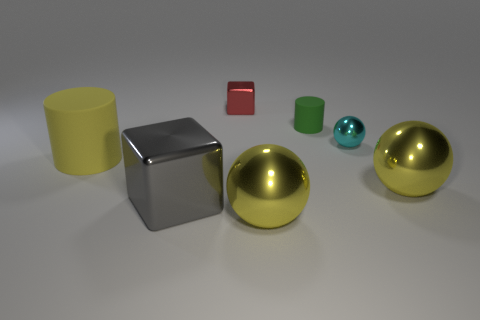Imagining this as an art piece, what concept could it be conveying? Viewing this assembly as an art piece, it might be interpreted as a commentary on order and chaos, the juxtaposition of various geometric forms and finishes could symbolize the diversity of elements in a unified system. The arrangement of the objects, all equidistant and orderly, introduces themes of structure and symmetry, while the different colors and materials can signify diversity within unity. The scene's minimalist aesthetic could further emphasize purity of form and the essence of materiality. 